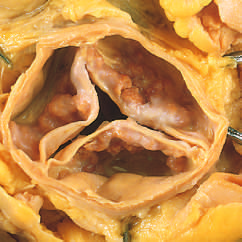what are nodular masses of calcium heaped up within?
Answer the question using a single word or phrase. The sinuses valsalva 